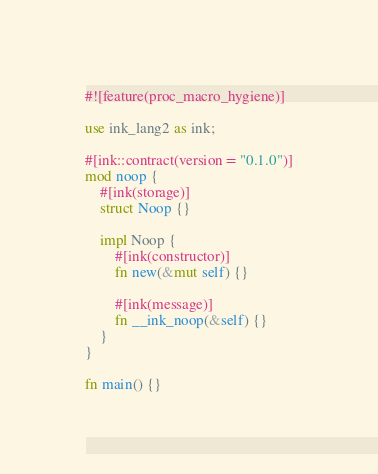<code> <loc_0><loc_0><loc_500><loc_500><_Rust_>#![feature(proc_macro_hygiene)]

use ink_lang2 as ink;

#[ink::contract(version = "0.1.0")]
mod noop {
    #[ink(storage)]
    struct Noop {}

    impl Noop {
        #[ink(constructor)]
        fn new(&mut self) {}

        #[ink(message)]
        fn __ink_noop(&self) {}
    }
}

fn main() {}
</code> 